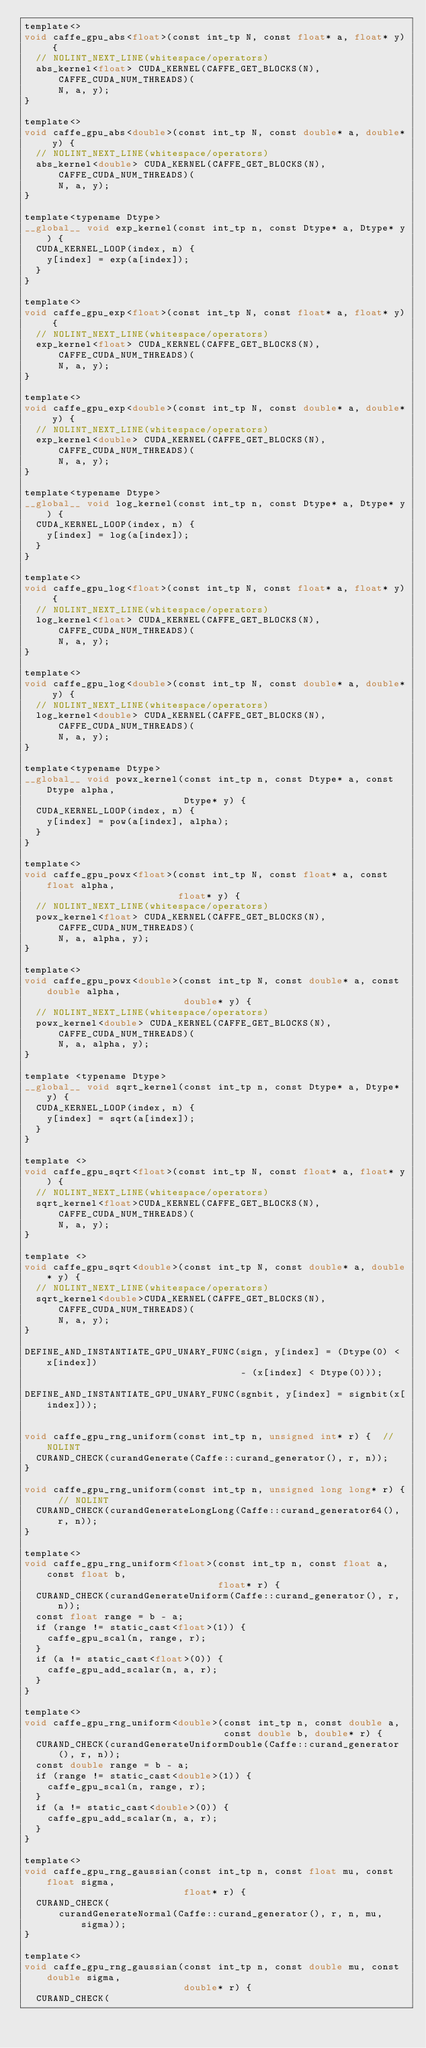<code> <loc_0><loc_0><loc_500><loc_500><_Cuda_>template<>
void caffe_gpu_abs<float>(const int_tp N, const float* a, float* y) {
  // NOLINT_NEXT_LINE(whitespace/operators)
  abs_kernel<float> CUDA_KERNEL(CAFFE_GET_BLOCKS(N), CAFFE_CUDA_NUM_THREADS)(
      N, a, y);
}

template<>
void caffe_gpu_abs<double>(const int_tp N, const double* a, double* y) {
  // NOLINT_NEXT_LINE(whitespace/operators)
  abs_kernel<double> CUDA_KERNEL(CAFFE_GET_BLOCKS(N), CAFFE_CUDA_NUM_THREADS)(
      N, a, y);
}

template<typename Dtype>
__global__ void exp_kernel(const int_tp n, const Dtype* a, Dtype* y) {
  CUDA_KERNEL_LOOP(index, n) {
    y[index] = exp(a[index]);
  }
}

template<>
void caffe_gpu_exp<float>(const int_tp N, const float* a, float* y) {
  // NOLINT_NEXT_LINE(whitespace/operators)
  exp_kernel<float> CUDA_KERNEL(CAFFE_GET_BLOCKS(N), CAFFE_CUDA_NUM_THREADS)(
      N, a, y);
}

template<>
void caffe_gpu_exp<double>(const int_tp N, const double* a, double* y) {
  // NOLINT_NEXT_LINE(whitespace/operators)
  exp_kernel<double> CUDA_KERNEL(CAFFE_GET_BLOCKS(N), CAFFE_CUDA_NUM_THREADS)(
      N, a, y);
}

template<typename Dtype>
__global__ void log_kernel(const int_tp n, const Dtype* a, Dtype* y) {
  CUDA_KERNEL_LOOP(index, n) {
    y[index] = log(a[index]);
  }
}

template<>
void caffe_gpu_log<float>(const int_tp N, const float* a, float* y) {
  // NOLINT_NEXT_LINE(whitespace/operators)
  log_kernel<float> CUDA_KERNEL(CAFFE_GET_BLOCKS(N), CAFFE_CUDA_NUM_THREADS)(
      N, a, y);
}

template<>
void caffe_gpu_log<double>(const int_tp N, const double* a, double* y) {
  // NOLINT_NEXT_LINE(whitespace/operators)
  log_kernel<double> CUDA_KERNEL(CAFFE_GET_BLOCKS(N), CAFFE_CUDA_NUM_THREADS)(
      N, a, y);
}

template<typename Dtype>
__global__ void powx_kernel(const int_tp n, const Dtype* a, const Dtype alpha,
                            Dtype* y) {
  CUDA_KERNEL_LOOP(index, n) {
    y[index] = pow(a[index], alpha);
  }
}

template<>
void caffe_gpu_powx<float>(const int_tp N, const float* a, const float alpha,
                           float* y) {
  // NOLINT_NEXT_LINE(whitespace/operators)
  powx_kernel<float> CUDA_KERNEL(CAFFE_GET_BLOCKS(N), CAFFE_CUDA_NUM_THREADS)(
      N, a, alpha, y);
}

template<>
void caffe_gpu_powx<double>(const int_tp N, const double* a, const double alpha,
                            double* y) {
  // NOLINT_NEXT_LINE(whitespace/operators)
  powx_kernel<double> CUDA_KERNEL(CAFFE_GET_BLOCKS(N), CAFFE_CUDA_NUM_THREADS)(
      N, a, alpha, y);
}

template <typename Dtype>
__global__ void sqrt_kernel(const int_tp n, const Dtype* a, Dtype* y) {
  CUDA_KERNEL_LOOP(index, n) {
    y[index] = sqrt(a[index]);
  }
}

template <>
void caffe_gpu_sqrt<float>(const int_tp N, const float* a, float* y) {
  // NOLINT_NEXT_LINE(whitespace/operators)
  sqrt_kernel<float>CUDA_KERNEL(CAFFE_GET_BLOCKS(N), CAFFE_CUDA_NUM_THREADS)(
      N, a, y);
}

template <>
void caffe_gpu_sqrt<double>(const int_tp N, const double* a, double* y) {
  // NOLINT_NEXT_LINE(whitespace/operators)
  sqrt_kernel<double>CUDA_KERNEL(CAFFE_GET_BLOCKS(N), CAFFE_CUDA_NUM_THREADS)(
      N, a, y);
}

DEFINE_AND_INSTANTIATE_GPU_UNARY_FUNC(sign, y[index] = (Dtype(0) < x[index])
                                      - (x[index] < Dtype(0)));

DEFINE_AND_INSTANTIATE_GPU_UNARY_FUNC(sgnbit, y[index] = signbit(x[index]));


void caffe_gpu_rng_uniform(const int_tp n, unsigned int* r) {  // NOLINT
  CURAND_CHECK(curandGenerate(Caffe::curand_generator(), r, n));
}

void caffe_gpu_rng_uniform(const int_tp n, unsigned long long* r) {  // NOLINT
  CURAND_CHECK(curandGenerateLongLong(Caffe::curand_generator64(), r, n));
}

template<>
void caffe_gpu_rng_uniform<float>(const int_tp n, const float a, const float b,
                                  float* r) {
  CURAND_CHECK(curandGenerateUniform(Caffe::curand_generator(), r, n));
  const float range = b - a;
  if (range != static_cast<float>(1)) {
    caffe_gpu_scal(n, range, r);
  }
  if (a != static_cast<float>(0)) {
    caffe_gpu_add_scalar(n, a, r);
  }
}

template<>
void caffe_gpu_rng_uniform<double>(const int_tp n, const double a,
                                   const double b, double* r) {
  CURAND_CHECK(curandGenerateUniformDouble(Caffe::curand_generator(), r, n));
  const double range = b - a;
  if (range != static_cast<double>(1)) {
    caffe_gpu_scal(n, range, r);
  }
  if (a != static_cast<double>(0)) {
    caffe_gpu_add_scalar(n, a, r);
  }
}

template<>
void caffe_gpu_rng_gaussian(const int_tp n, const float mu, const float sigma,
                            float* r) {
  CURAND_CHECK(
      curandGenerateNormal(Caffe::curand_generator(), r, n, mu, sigma));
}

template<>
void caffe_gpu_rng_gaussian(const int_tp n, const double mu, const double sigma,
                            double* r) {
  CURAND_CHECK(</code> 